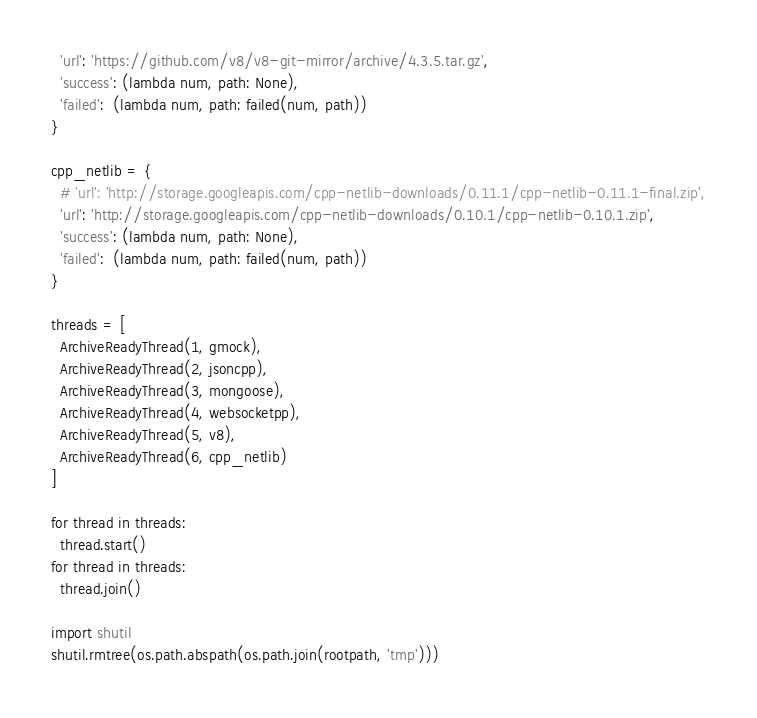<code> <loc_0><loc_0><loc_500><loc_500><_Python_>  'url': 'https://github.com/v8/v8-git-mirror/archive/4.3.5.tar.gz',
  'success': (lambda num, path: None),
  'failed':  (lambda num, path: failed(num, path))
}

cpp_netlib = {
  # 'url': 'http://storage.googleapis.com/cpp-netlib-downloads/0.11.1/cpp-netlib-0.11.1-final.zip',
  'url': 'http://storage.googleapis.com/cpp-netlib-downloads/0.10.1/cpp-netlib-0.10.1.zip',
  'success': (lambda num, path: None),
  'failed':  (lambda num, path: failed(num, path))
}

threads = [
  ArchiveReadyThread(1, gmock),
  ArchiveReadyThread(2, jsoncpp),
  ArchiveReadyThread(3, mongoose),
  ArchiveReadyThread(4, websocketpp),
  ArchiveReadyThread(5, v8),
  ArchiveReadyThread(6, cpp_netlib)
]

for thread in threads:
  thread.start()
for thread in threads:
  thread.join()

import shutil
shutil.rmtree(os.path.abspath(os.path.join(rootpath, 'tmp')))
</code> 